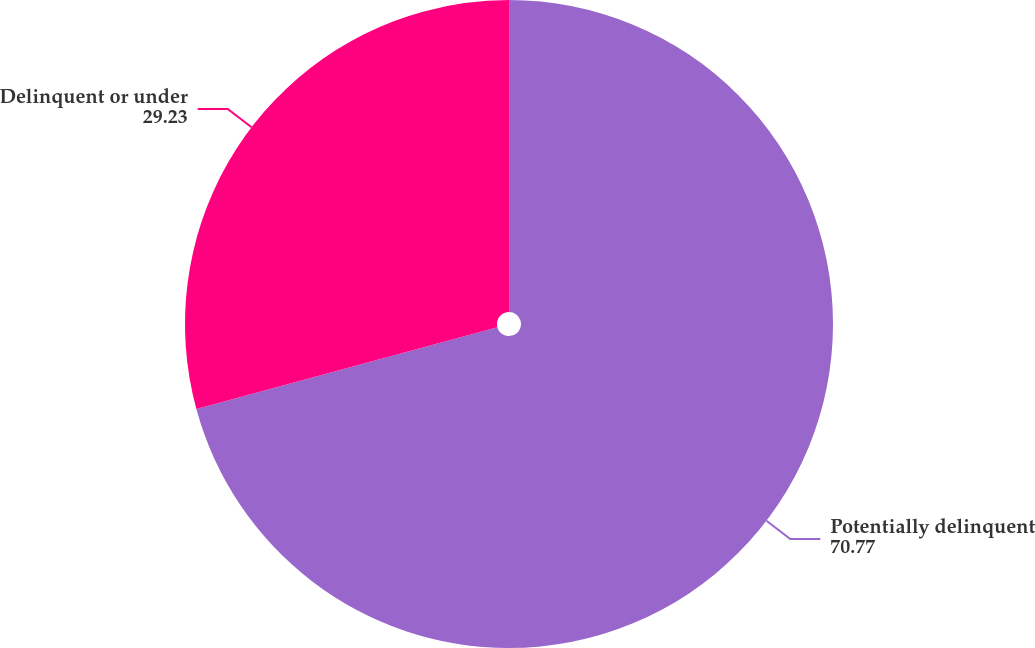Convert chart. <chart><loc_0><loc_0><loc_500><loc_500><pie_chart><fcel>Potentially delinquent<fcel>Delinquent or under<nl><fcel>70.77%<fcel>29.23%<nl></chart> 